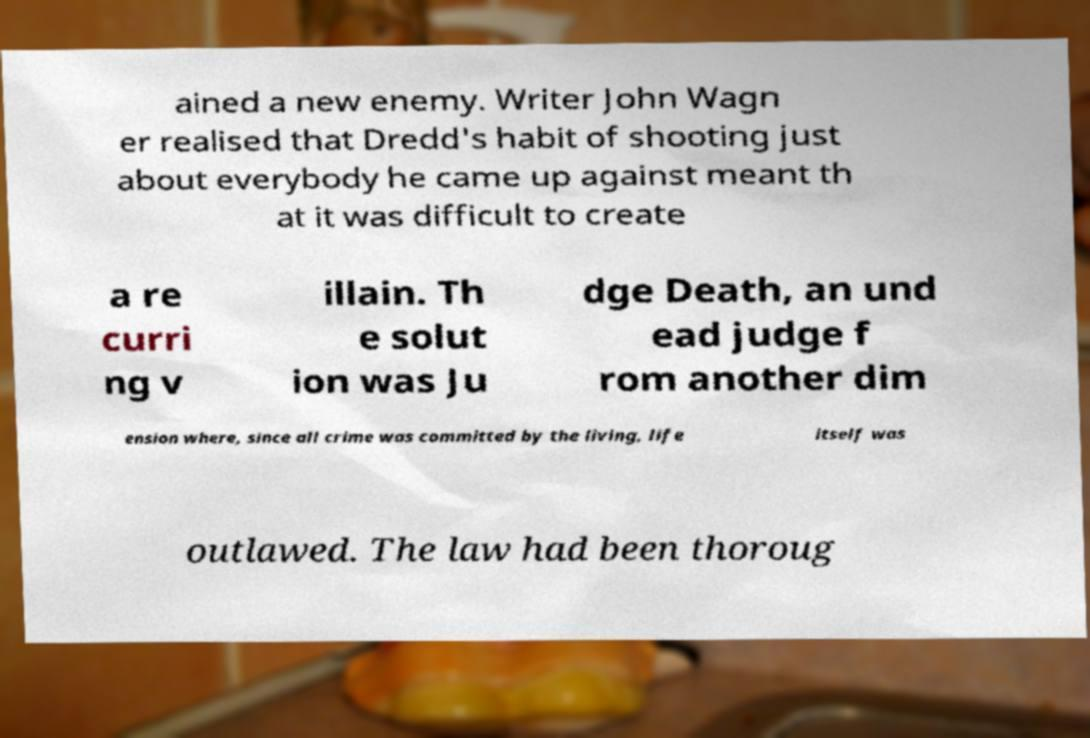Please read and relay the text visible in this image. What does it say? ained a new enemy. Writer John Wagn er realised that Dredd's habit of shooting just about everybody he came up against meant th at it was difficult to create a re curri ng v illain. Th e solut ion was Ju dge Death, an und ead judge f rom another dim ension where, since all crime was committed by the living, life itself was outlawed. The law had been thoroug 